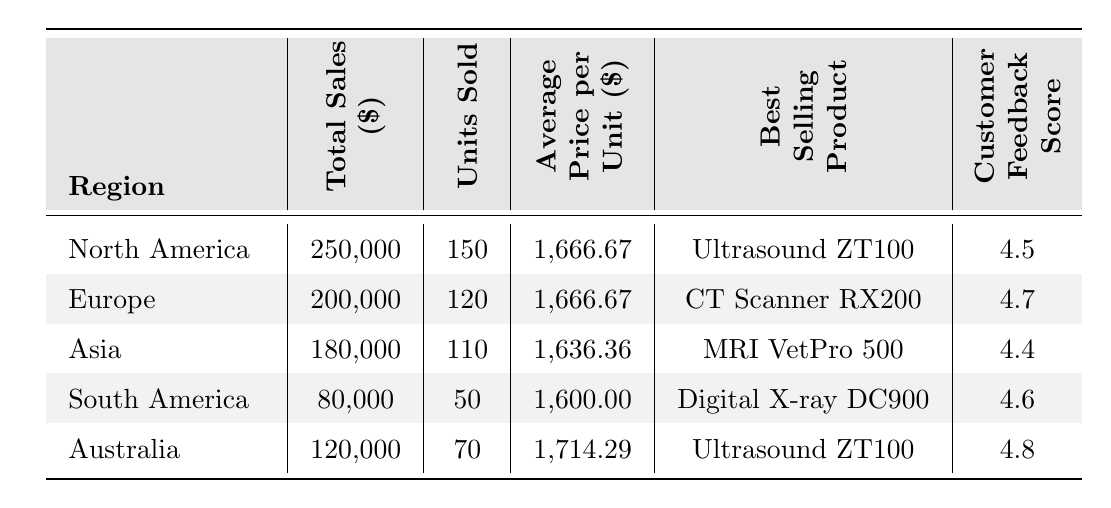What is the total sales in North America? The table lists North America with a total sales figure of 250,000 dollars.
Answer: 250,000 Which region had the highest customer feedback score? By comparing the customer feedback scores listed in the table, Australia has the highest score of 4.8.
Answer: Australia What is the average price per unit for the CT Scanner RX200? The table shows that the average price per unit in Europe, where the CT Scanner RX200 is the best-selling product, is 1,666.67 dollars.
Answer: 1,666.67 How many more units were sold in North America compared to South America? The units sold in North America are 150, while in South America they are 50. The difference is 150 - 50 = 100 units more sold in North America.
Answer: 100 What is the total sales across all regions? Adding the total sales from all regions: 250,000 + 200,000 + 180,000 + 80,000 + 120,000 = 830,000 dollars.
Answer: 830,000 Is the average price per unit for MRI VetPro 500 lower than that of Digital X-ray DC900? The average price per unit for MRI VetPro 500 is 1,636.36 dollars, while for Digital X-ray DC900 it is 1,600.00 dollars. Since 1,636.36 is greater than 1,600.00, the answer is no.
Answer: No What is the total sales amount for Europe and Asia combined? Adding the total sales for Europe (200,000) and Asia (180,000): 200,000 + 180,000 = 380,000 dollars.
Answer: 380,000 Which product was the best-selling in the highest sales region? The highest sales region is North America, with total sales of 250,000 dollars, where the best-selling product is the Ultrasound ZT100.
Answer: Ultrasound ZT100 What percentage of total sales did South America contribute? South America's total sales are 80,000. To find the percentage: (80,000 / 830,000) * 100 = 9.64%.
Answer: 9.64% Which regions have an average price per unit above 1,650 dollars? The regions with an average price per unit above 1,650 dollars are North America (1,666.67), Europe (1,666.67), and Australia (1,714.29).
Answer: North America, Europe, Australia 